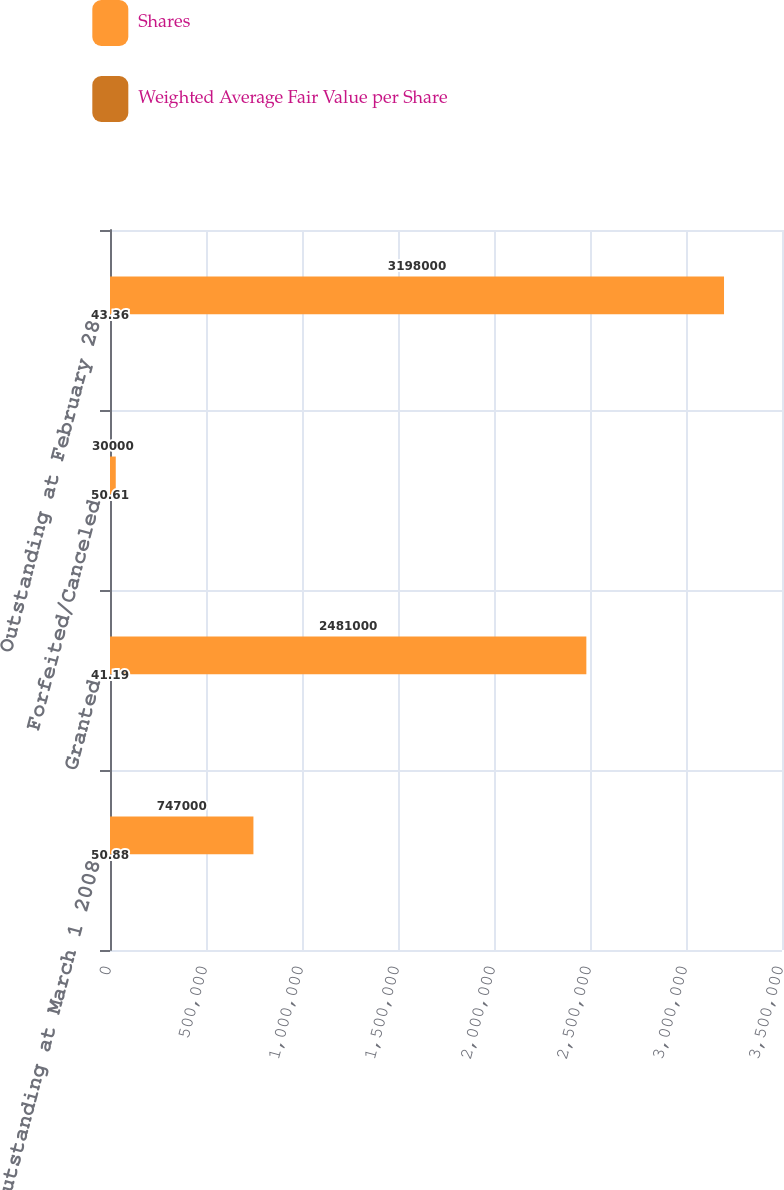Convert chart. <chart><loc_0><loc_0><loc_500><loc_500><stacked_bar_chart><ecel><fcel>Outstanding at March 1 2008<fcel>Granted<fcel>Forfeited/Canceled<fcel>Outstanding at February 28<nl><fcel>Shares<fcel>747000<fcel>2.481e+06<fcel>30000<fcel>3.198e+06<nl><fcel>Weighted Average Fair Value per Share<fcel>50.88<fcel>41.19<fcel>50.61<fcel>43.36<nl></chart> 